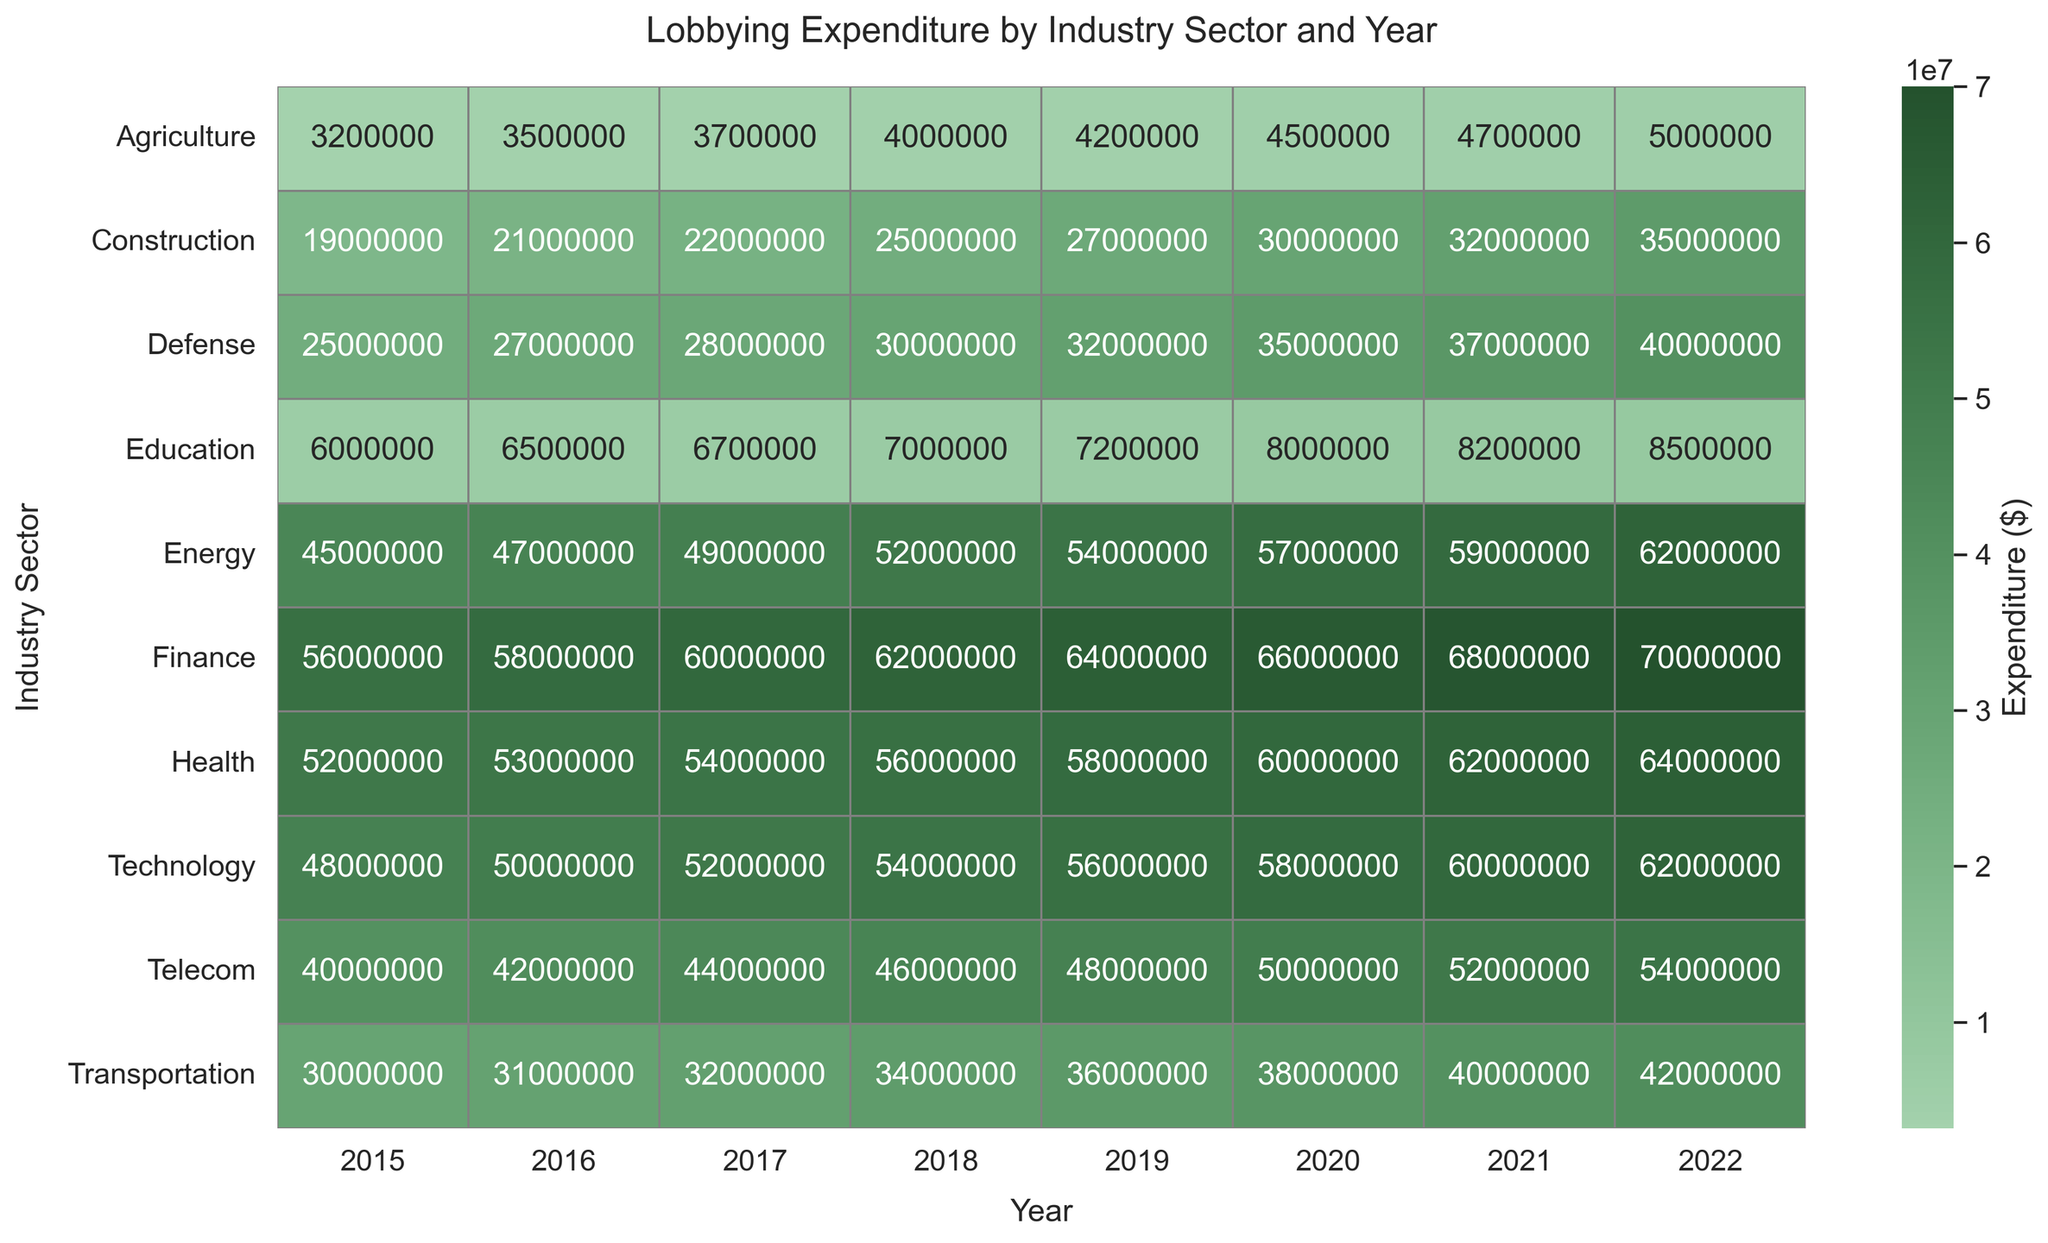What year had the highest lobbying expenditure in the Technology sector? From the heatmap, locate the row corresponding to the Technology sector and identify the year with the highest value.
Answer: 2022 Which industry sector saw the largest increase in lobbying expenditure from 2015 to 2022? Identify the difference in values for each sector between 2022 and 2015 from the heatmap and determine the sector with the largest positive change.
Answer: Finance Compare the lobbying expenditures between the Health and Energy sectors in 2021. Which one was higher and by how much? Locate both the Health and Energy sectors for the year 2021 on the heatmap, find their expenditures, and then subtract the smaller value from the larger one to find the difference.
Answer: Health, $3,000,000 Which sector consistently showed increasing expenditure over the years from 2015 to 2022? Look at the heatmap to see which sector has values that continuously increase each year from 2015 to 2022.
Answer: Finance Find the total lobbying expenditure for the Agriculture sector from 2015 to 2022. Add up the values for the Agriculture sector for each year from the heatmap.
Answer: $38,250,000 In which year did the Education sector have the least lobbying expenditure? Find the row for the Education sector and identify the year with the smallest value.
Answer: 2015 Which sector had the highest expenditure in 2018, and what was that value? Look at the heatmap for the year 2018 and identify the highest value and the corresponding sector.
Answer: Finance, $62,000,000 What is the average annual lobbying expenditure for the Defense sector from 2015 to 2022? Sum the lobbying expenditures for the Defense sector from 2015 to 2022 and divide by the number of years (8).
Answer: $31,125,000 Did the Telecom sector's lobbying expenditure ever exceed $50,000,000? If so, in which year(s)? Check the values for the Telecom sector across all years and identify any year(s) where the expenditure exceeds $50,000,000.
Answer: Yes, 2020 and 2021 